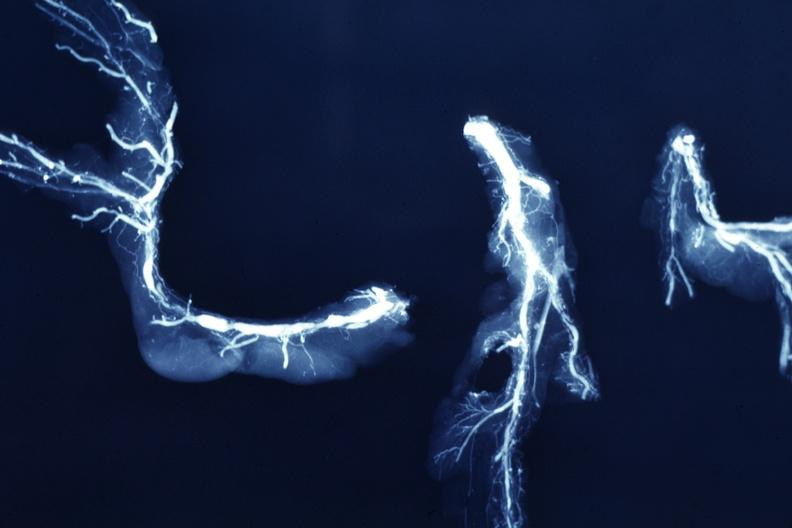s vasculature present?
Answer the question using a single word or phrase. Yes 